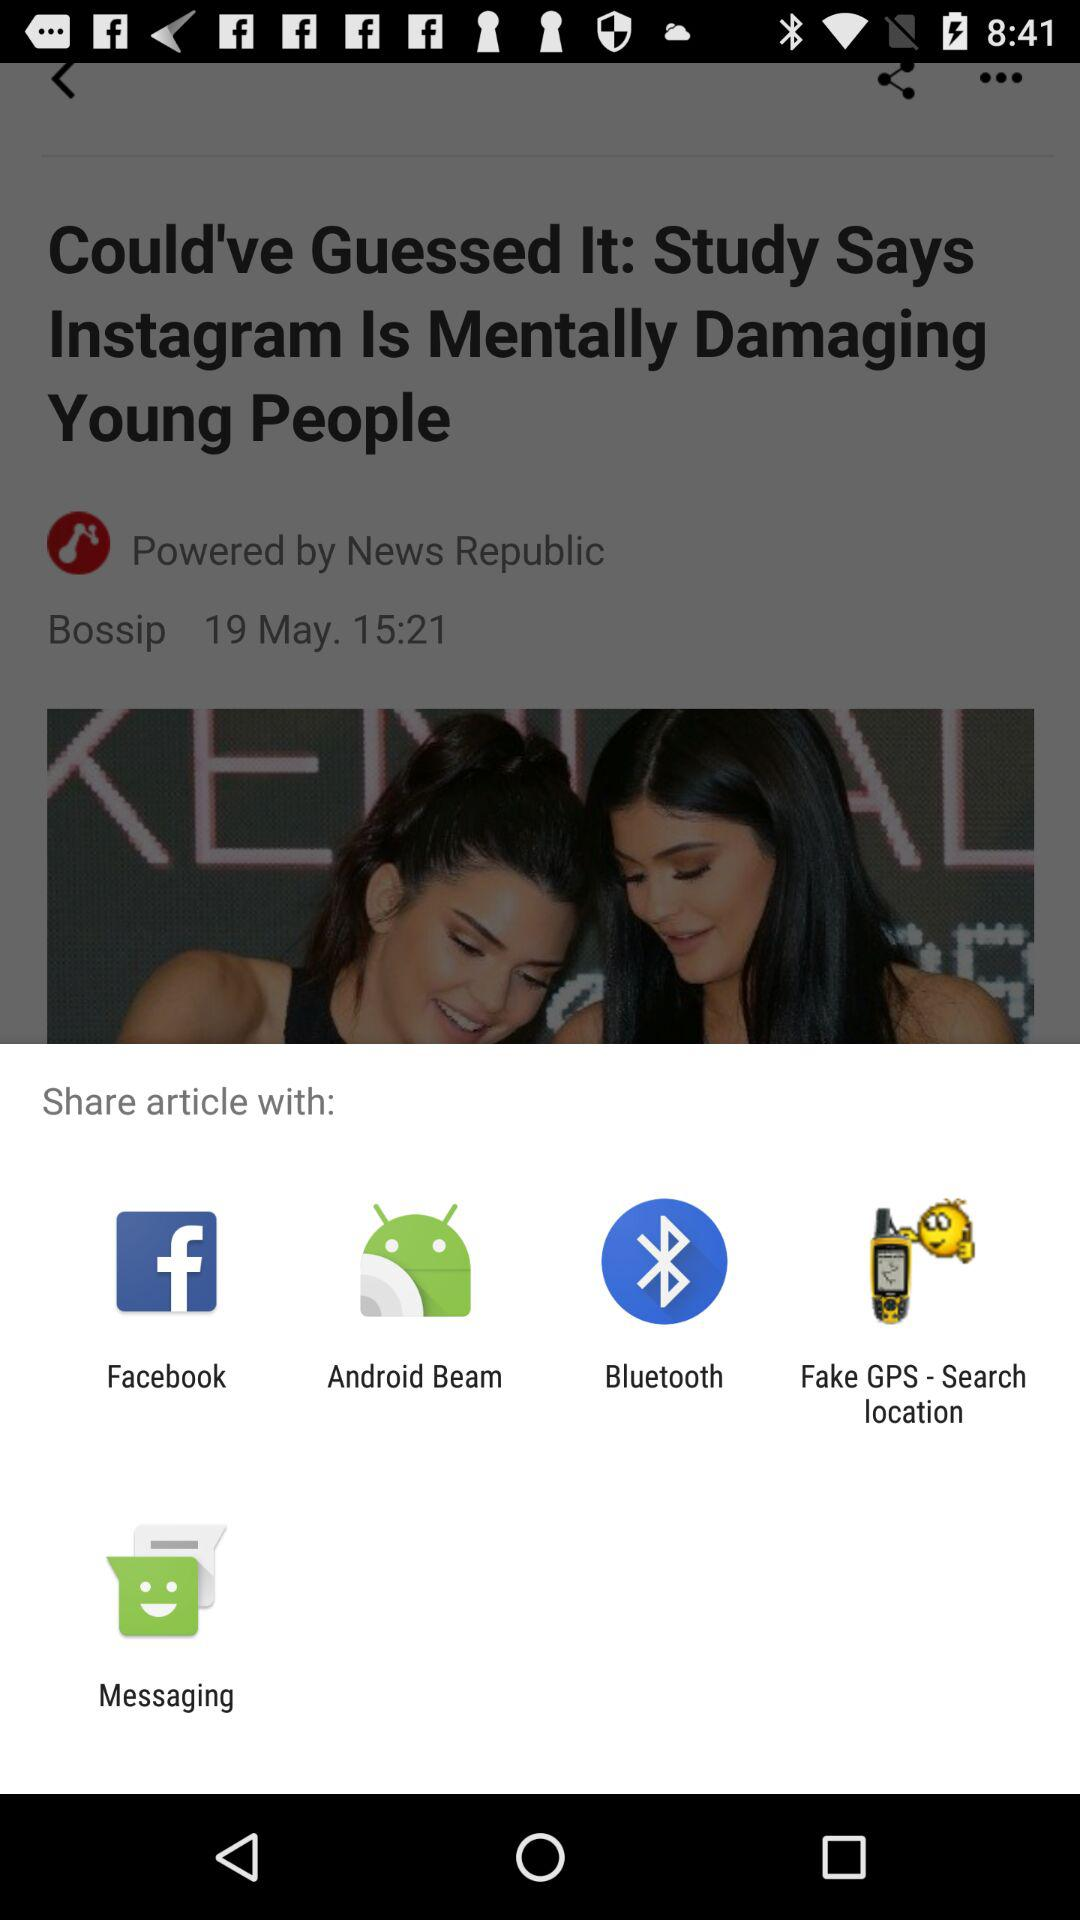What time did the article get posted? The article was posted at 15:21. 